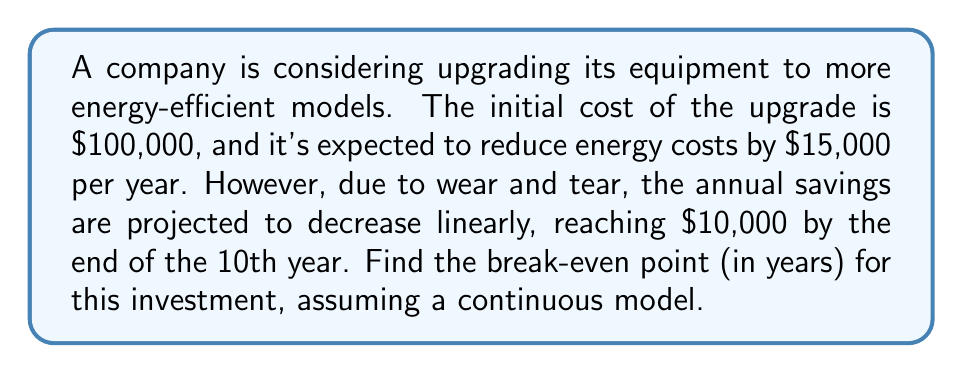Solve this math problem. To solve this problem, we need to follow these steps:

1) First, let's model the annual savings as a function of time. We know it starts at $15,000 and decreases linearly to $10,000 over 10 years. We can represent this with the linear function:

   $S(t) = 15000 - 500t$, where $t$ is the time in years.

2) The total savings up to time $t$ is the integral of this function from 0 to $t$:

   $\int_0^t S(t) dt = \int_0^t (15000 - 500t) dt$

3) Solving this integral:

   $\int_0^t (15000 - 500t) dt = [15000t - 250t^2]_0^t = 15000t - 250t^2$

4) The break-even point occurs when the total savings equal the initial investment. We can express this as an equation:

   $15000t - 250t^2 = 100000$

5) Rearranging this into standard quadratic form:

   $250t^2 - 15000t + 100000 = 0$

6) We can solve this using the quadratic formula: $t = \frac{-b \pm \sqrt{b^2 - 4ac}}{2a}$

   Where $a = 250$, $b = -15000$, and $c = 100000$

7) Plugging in these values:

   $t = \frac{15000 \pm \sqrt{225000000 - 100000000}}{500}$

8) Simplifying:

   $t = \frac{15000 \pm \sqrt{125000000}}{500} = \frac{15000 \pm 11180.34}{500}$

9) This gives us two solutions:

   $t_1 = \frac{15000 + 11180.34}{500} \approx 52.36$ years
   $t_2 = \frac{15000 - 11180.34}{500} \approx 7.64$ years

10) Since we're looking for the break-even point, we choose the smaller, positive solution.
Answer: $7.64$ years 